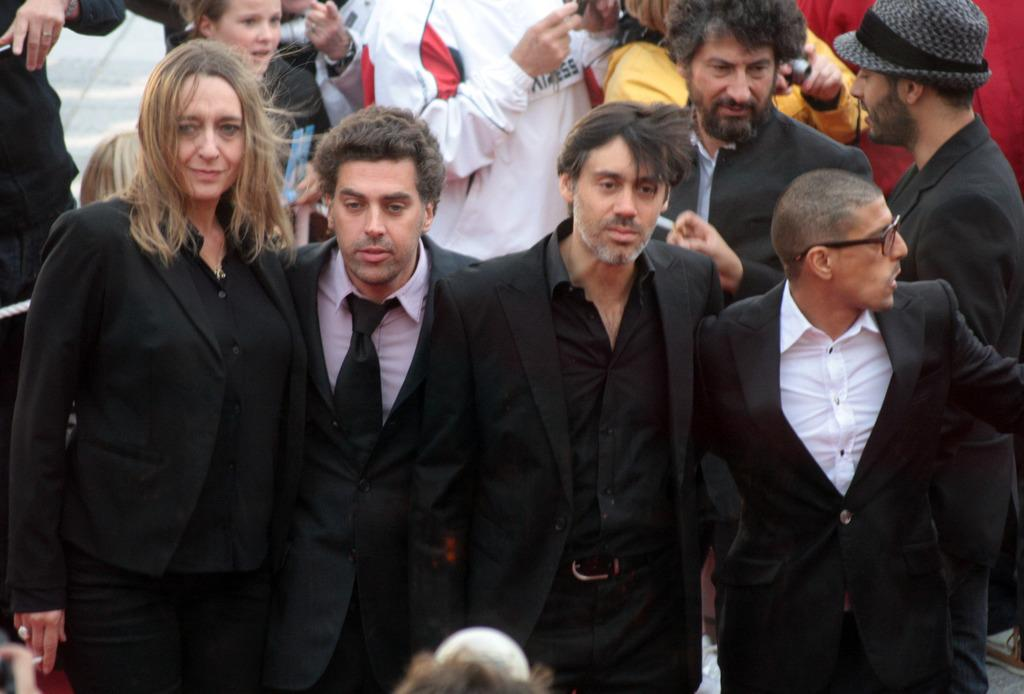How many people are in the image? There are many people in the image. What color dress are some of the persons wearing? Some persons are wearing black dress. Where are the persons wearing black dress located in the image? The persons wearing black dress are standing in the front. What type of linen is being used to dry the clothes in the image? There is no mention of clothes or linen in the image; it features a group of people. How does the summer weather affect the people in the image? The provided facts do not mention the weather or season, so we cannot determine how summer weather might affect the people in the image. 